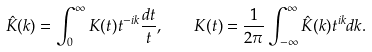<formula> <loc_0><loc_0><loc_500><loc_500>\hat { K } ( k ) = \int _ { 0 } ^ { \infty } K ( t ) t ^ { - i k } \frac { d t } { t } , \quad K ( t ) = \frac { 1 } { 2 \pi } \int _ { - \infty } ^ { \infty } \hat { K } ( k ) t ^ { i k } d k .</formula> 